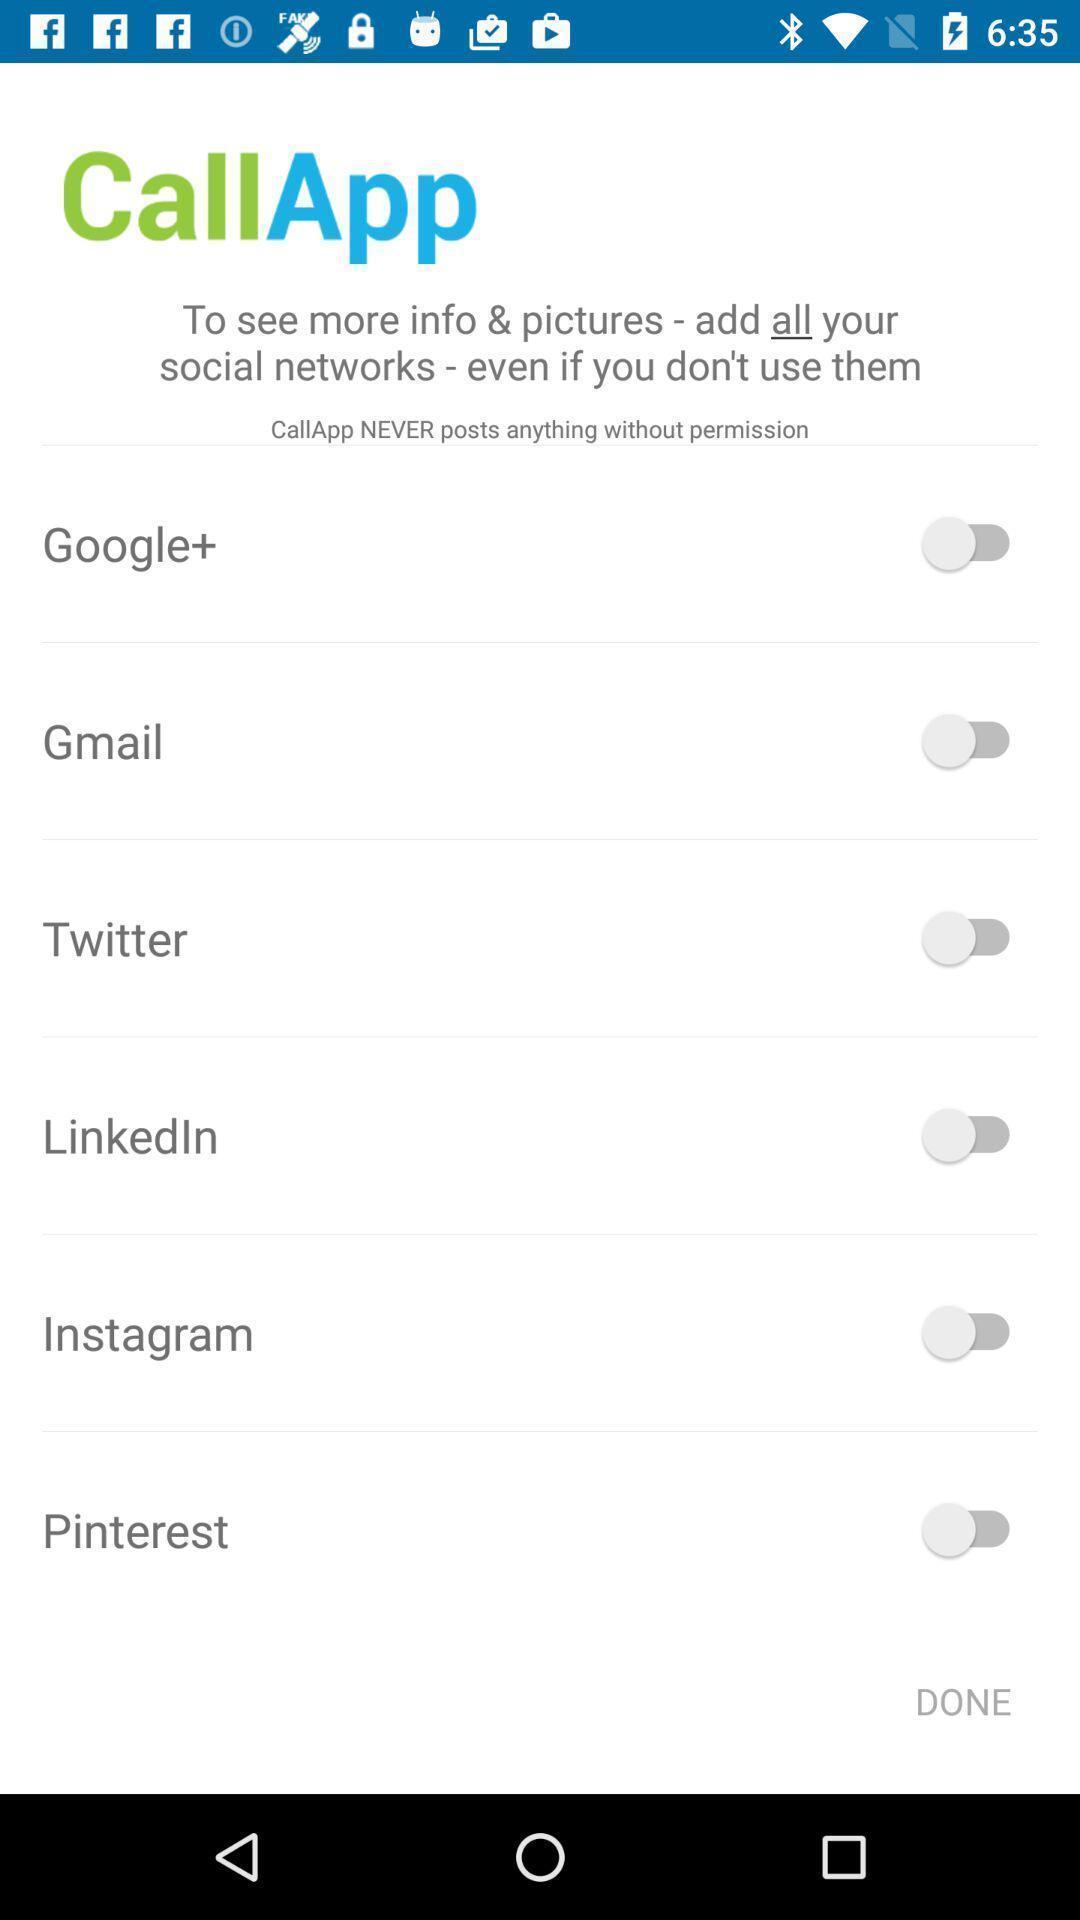Describe the key features of this screenshot. Screen displaying the list of social apps with toggle icons. 